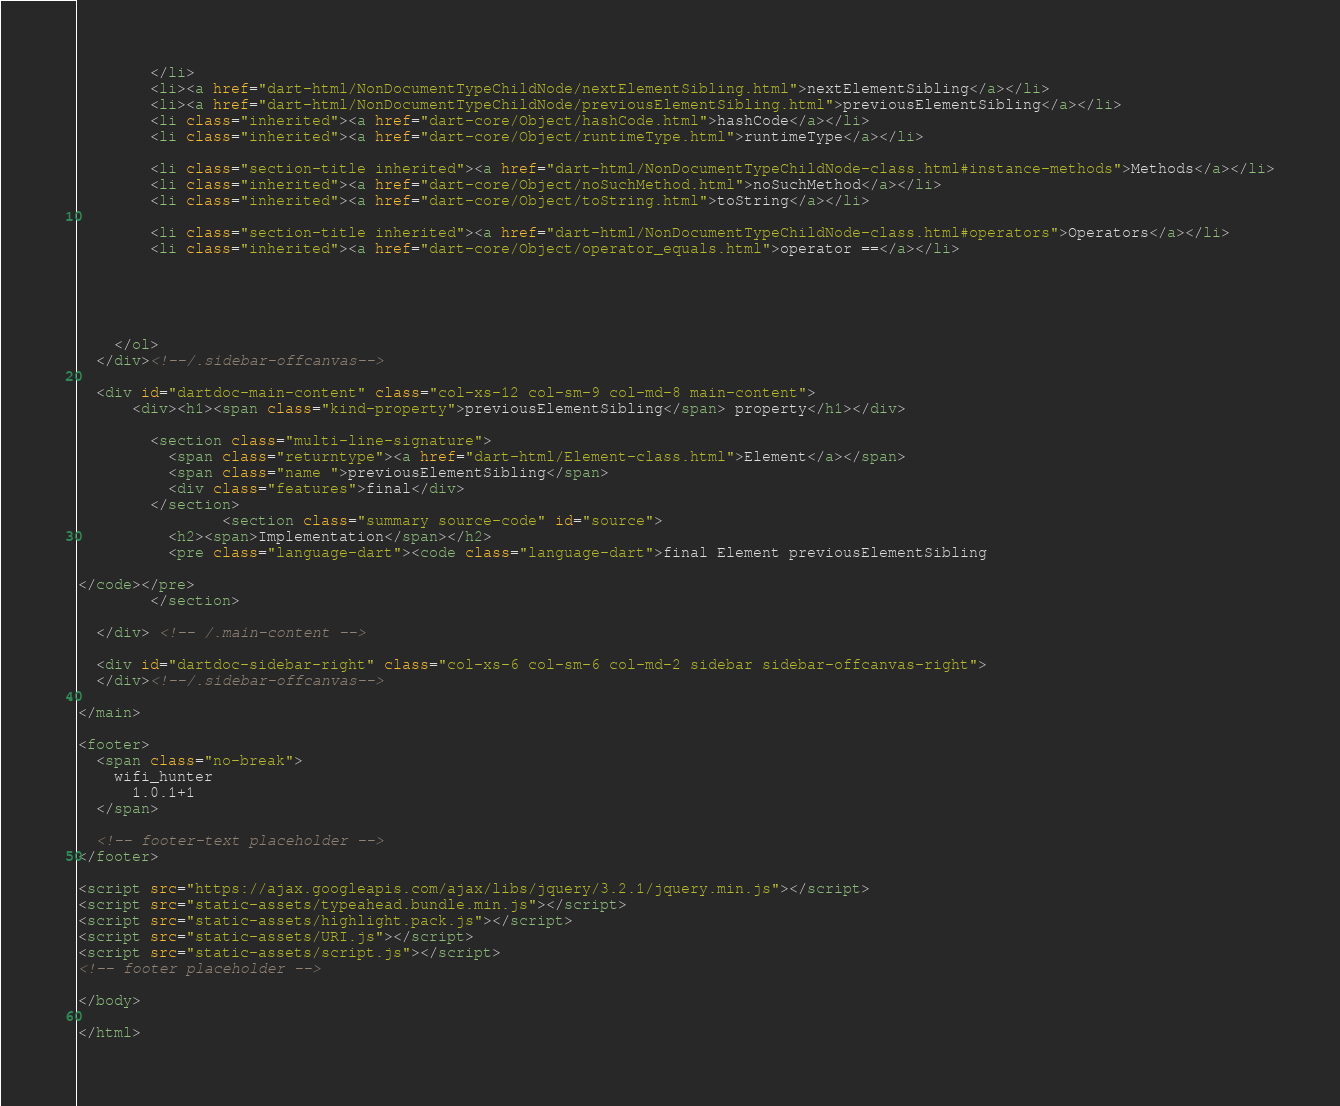Convert code to text. <code><loc_0><loc_0><loc_500><loc_500><_HTML_>        </li>
        <li><a href="dart-html/NonDocumentTypeChildNode/nextElementSibling.html">nextElementSibling</a></li>
        <li><a href="dart-html/NonDocumentTypeChildNode/previousElementSibling.html">previousElementSibling</a></li>
        <li class="inherited"><a href="dart-core/Object/hashCode.html">hashCode</a></li>
        <li class="inherited"><a href="dart-core/Object/runtimeType.html">runtimeType</a></li>
    
        <li class="section-title inherited"><a href="dart-html/NonDocumentTypeChildNode-class.html#instance-methods">Methods</a></li>
        <li class="inherited"><a href="dart-core/Object/noSuchMethod.html">noSuchMethod</a></li>
        <li class="inherited"><a href="dart-core/Object/toString.html">toString</a></li>
    
        <li class="section-title inherited"><a href="dart-html/NonDocumentTypeChildNode-class.html#operators">Operators</a></li>
        <li class="inherited"><a href="dart-core/Object/operator_equals.html">operator ==</a></li>
    
    
    
    
    
    </ol>
  </div><!--/.sidebar-offcanvas-->

  <div id="dartdoc-main-content" class="col-xs-12 col-sm-9 col-md-8 main-content">
      <div><h1><span class="kind-property">previousElementSibling</span> property</h1></div>

        <section class="multi-line-signature">
          <span class="returntype"><a href="dart-html/Element-class.html">Element</a></span>
          <span class="name ">previousElementSibling</span>
          <div class="features">final</div>
        </section>
                <section class="summary source-code" id="source">
          <h2><span>Implementation</span></h2>
          <pre class="language-dart"><code class="language-dart">final Element previousElementSibling

</code></pre>
        </section>

  </div> <!-- /.main-content -->

  <div id="dartdoc-sidebar-right" class="col-xs-6 col-sm-6 col-md-2 sidebar sidebar-offcanvas-right">
  </div><!--/.sidebar-offcanvas-->

</main>

<footer>
  <span class="no-break">
    wifi_hunter
      1.0.1+1
  </span>

  <!-- footer-text placeholder -->
</footer>

<script src="https://ajax.googleapis.com/ajax/libs/jquery/3.2.1/jquery.min.js"></script>
<script src="static-assets/typeahead.bundle.min.js"></script>
<script src="static-assets/highlight.pack.js"></script>
<script src="static-assets/URI.js"></script>
<script src="static-assets/script.js"></script>
<!-- footer placeholder -->

</body>

</html>
</code> 